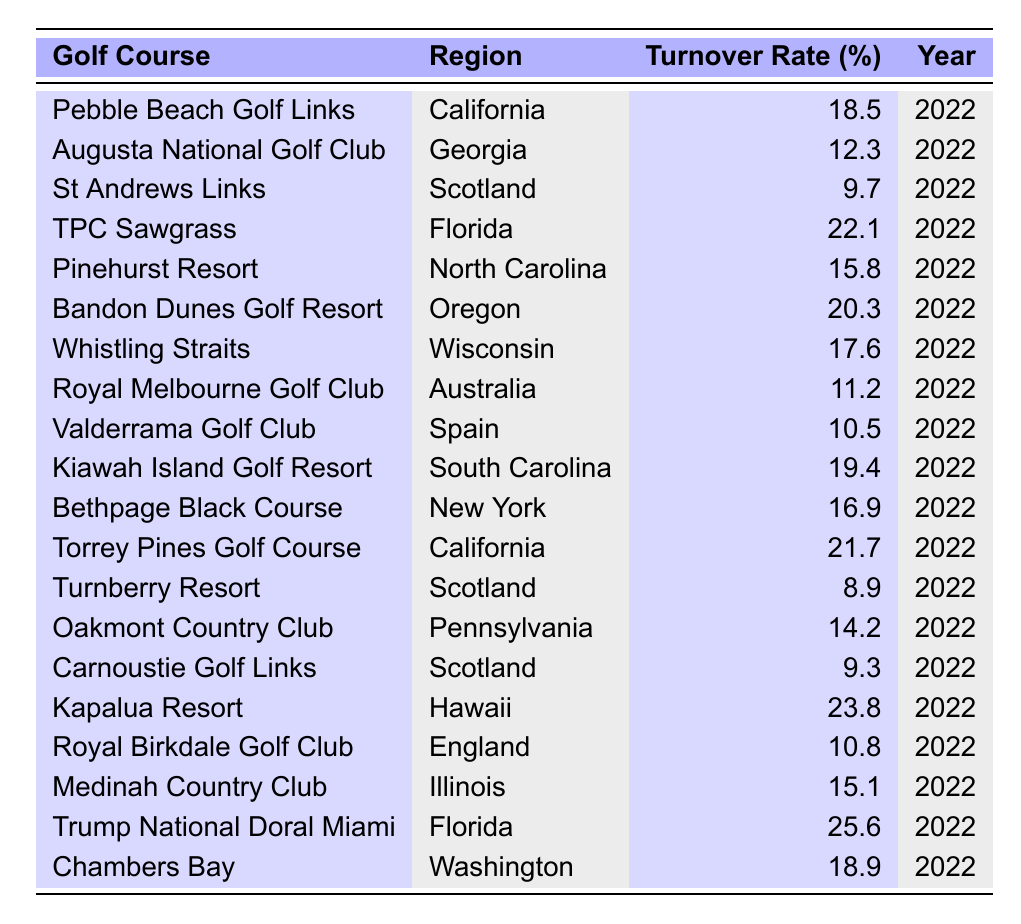What is the employee turnover rate for the Augusta National Golf Club? The turnover rate is directly listed in the table for the Augusta National Golf Club under the "Employee Turnover Rate (%)" column, which shows a value of 12.3 percent for the year 2022.
Answer: 12.3 Which golf course has the highest employee turnover rate in the table? By examining the "Employee Turnover Rate (%)" column, we find the highest value is 25.6 percent for Trump National Doral Miami.
Answer: Trump National Doral Miami What is the average employee turnover rate for golf courses located in California? The turnover rates for the two courses in California (Pebble Beach Golf Links: 18.5 and Torrey Pines Golf Course: 21.7) are summed as 18.5 + 21.7 = 40.2, divided by 2 for the average gives 40.2 / 2 = 20.1.
Answer: 20.1 Is the turnover rate at Turnberry Resort lower than the average turnover rate of golf courses located in Scotland? The turnover rates for Scotland are St Andrews Links: 9.7, Turnberry Resort: 8.9, and Carnoustie Golf Links: 9.3. The average is (9.7 + 8.9 + 9.3) / 3 = 9.3. Since 8.9 (Turnberry) is less than 9.3, the statement is true.
Answer: Yes How much higher is the turnover rate at Kiawah Island Golf Resort compared to the average turnover rate of courses in the Southeast (Florida, Georgia, South Carolina)? The turnover rates in the Southeast are 22.1 (Florida), 12.3 (Georgia), and 19.4 (South Carolina). The average is (22.1 + 12.3 + 19.4) / 3 = 17.9. Kiawah Island Golf Resort has a turnover rate of 19.4, which is 19.4 - 17.9 = 1.5 percent higher.
Answer: 1.5 Which region has the lowest overall employee turnover rate among the golf courses listed? The employee turnover rates for the regions are summarized: California (20.1 average), Georgia (12.3), Scotland (9.3 average), Florida (23.8 average), North Carolina (15.8), Oregon (20.3), Wisconsin (17.6), Australia (11.2), Spain (10.5), South Carolina (19.4), New York (16.9), Pennsylvania (14.2), Hawaii (23.8), Illinois (15.1), and Washington (18.9). The lowest average is from Scotland with an average of 9.3.
Answer: Scotland How many golf courses have a turnover rate above 20%? By counting the turnover rates from the table: TPC Sawgrass (22.1), Bandon Dunes Golf Resort (20.3), Kapalua Resort (23.8), and Trump National Doral Miami (25.6), we find there are 4 golf courses above 20%.
Answer: 4 